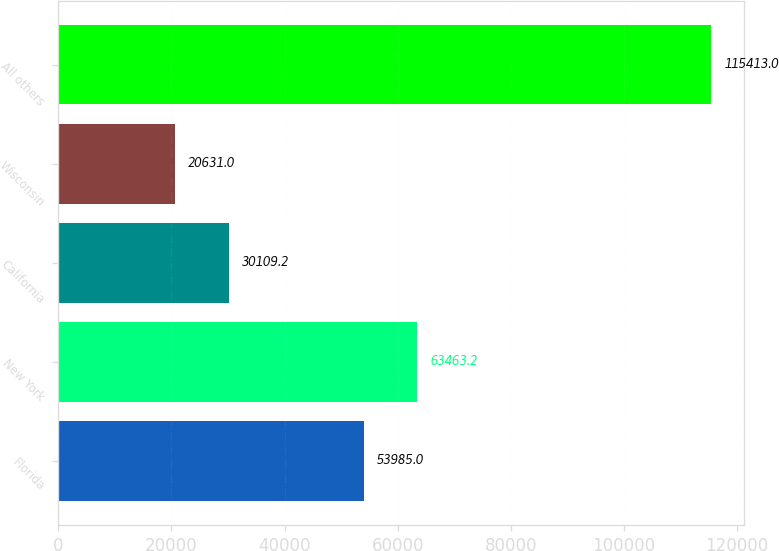<chart> <loc_0><loc_0><loc_500><loc_500><bar_chart><fcel>Florida<fcel>New York<fcel>California<fcel>Wisconsin<fcel>All others<nl><fcel>53985<fcel>63463.2<fcel>30109.2<fcel>20631<fcel>115413<nl></chart> 